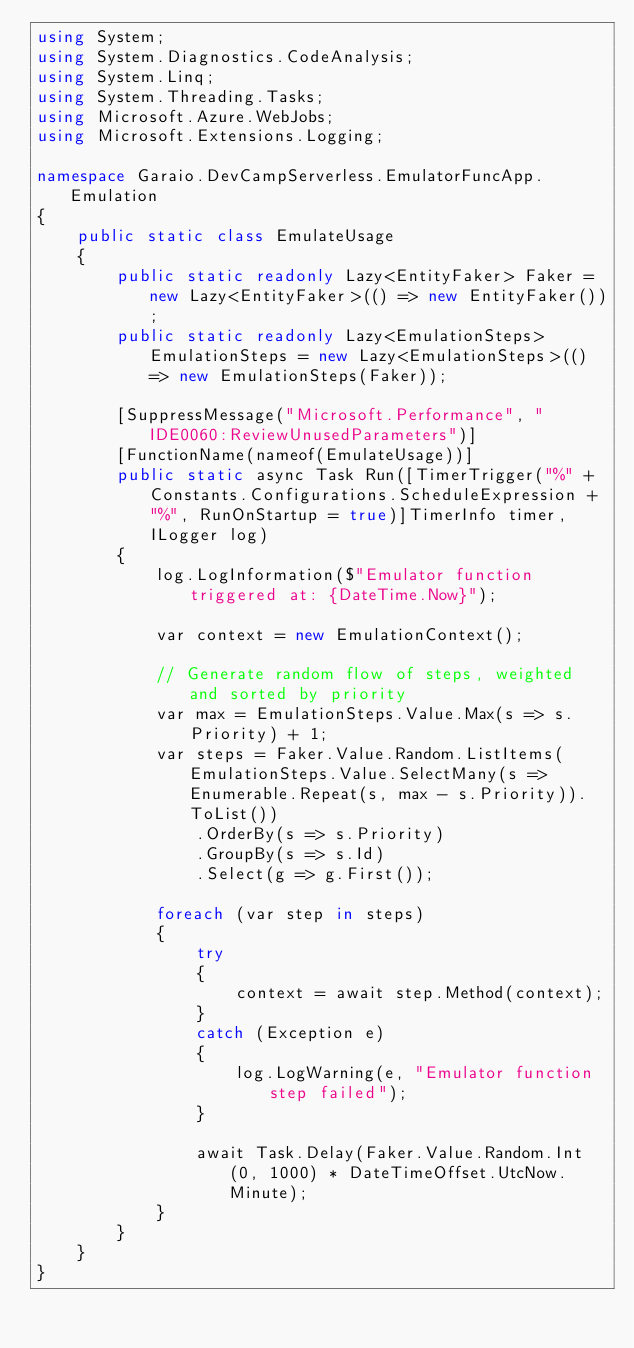Convert code to text. <code><loc_0><loc_0><loc_500><loc_500><_C#_>using System;
using System.Diagnostics.CodeAnalysis;
using System.Linq;
using System.Threading.Tasks;
using Microsoft.Azure.WebJobs;
using Microsoft.Extensions.Logging;

namespace Garaio.DevCampServerless.EmulatorFuncApp.Emulation
{
    public static class EmulateUsage
    {
        public static readonly Lazy<EntityFaker> Faker = new Lazy<EntityFaker>(() => new EntityFaker());
        public static readonly Lazy<EmulationSteps> EmulationSteps = new Lazy<EmulationSteps>(() => new EmulationSteps(Faker));

        [SuppressMessage("Microsoft.Performance", "IDE0060:ReviewUnusedParameters")]
        [FunctionName(nameof(EmulateUsage))]
        public static async Task Run([TimerTrigger("%" + Constants.Configurations.ScheduleExpression + "%", RunOnStartup = true)]TimerInfo timer, ILogger log)
        {
            log.LogInformation($"Emulator function triggered at: {DateTime.Now}");

            var context = new EmulationContext();

            // Generate random flow of steps, weighted and sorted by priority
            var max = EmulationSteps.Value.Max(s => s.Priority) + 1;
            var steps = Faker.Value.Random.ListItems(EmulationSteps.Value.SelectMany(s => Enumerable.Repeat(s, max - s.Priority)).ToList())
                .OrderBy(s => s.Priority)
                .GroupBy(s => s.Id)
                .Select(g => g.First());

            foreach (var step in steps)
            {
                try
                {
                    context = await step.Method(context);
                }
                catch (Exception e)
                {
                    log.LogWarning(e, "Emulator function step failed");
                }

                await Task.Delay(Faker.Value.Random.Int(0, 1000) * DateTimeOffset.UtcNow.Minute);
            }
        }
    }
}
</code> 